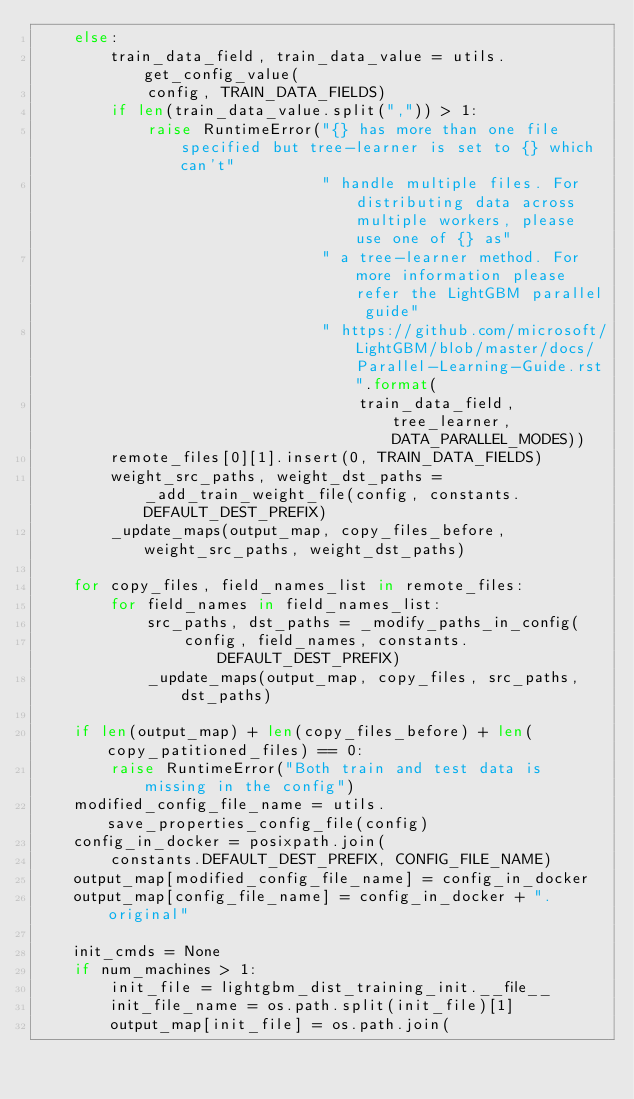Convert code to text. <code><loc_0><loc_0><loc_500><loc_500><_Python_>    else:
        train_data_field, train_data_value = utils.get_config_value(
            config, TRAIN_DATA_FIELDS)
        if len(train_data_value.split(",")) > 1:
            raise RuntimeError("{} has more than one file specified but tree-learner is set to {} which can't"
                               " handle multiple files. For distributing data across multiple workers, please use one of {} as"
                               " a tree-learner method. For more information please refer the LightGBM parallel guide"
                               " https://github.com/microsoft/LightGBM/blob/master/docs/Parallel-Learning-Guide.rst".format(
                                   train_data_field, tree_learner, DATA_PARALLEL_MODES))
        remote_files[0][1].insert(0, TRAIN_DATA_FIELDS)
        weight_src_paths, weight_dst_paths = _add_train_weight_file(config, constants.DEFAULT_DEST_PREFIX)
        _update_maps(output_map, copy_files_before, weight_src_paths, weight_dst_paths)

    for copy_files, field_names_list in remote_files:
        for field_names in field_names_list:
            src_paths, dst_paths = _modify_paths_in_config(
                config, field_names, constants.DEFAULT_DEST_PREFIX)
            _update_maps(output_map, copy_files, src_paths, dst_paths)

    if len(output_map) + len(copy_files_before) + len(copy_patitioned_files) == 0:
        raise RuntimeError("Both train and test data is missing in the config")
    modified_config_file_name = utils.save_properties_config_file(config)
    config_in_docker = posixpath.join(
        constants.DEFAULT_DEST_PREFIX, CONFIG_FILE_NAME)
    output_map[modified_config_file_name] = config_in_docker
    output_map[config_file_name] = config_in_docker + ".original"

    init_cmds = None
    if num_machines > 1:
        init_file = lightgbm_dist_training_init.__file__
        init_file_name = os.path.split(init_file)[1]
        output_map[init_file] = os.path.join(</code> 